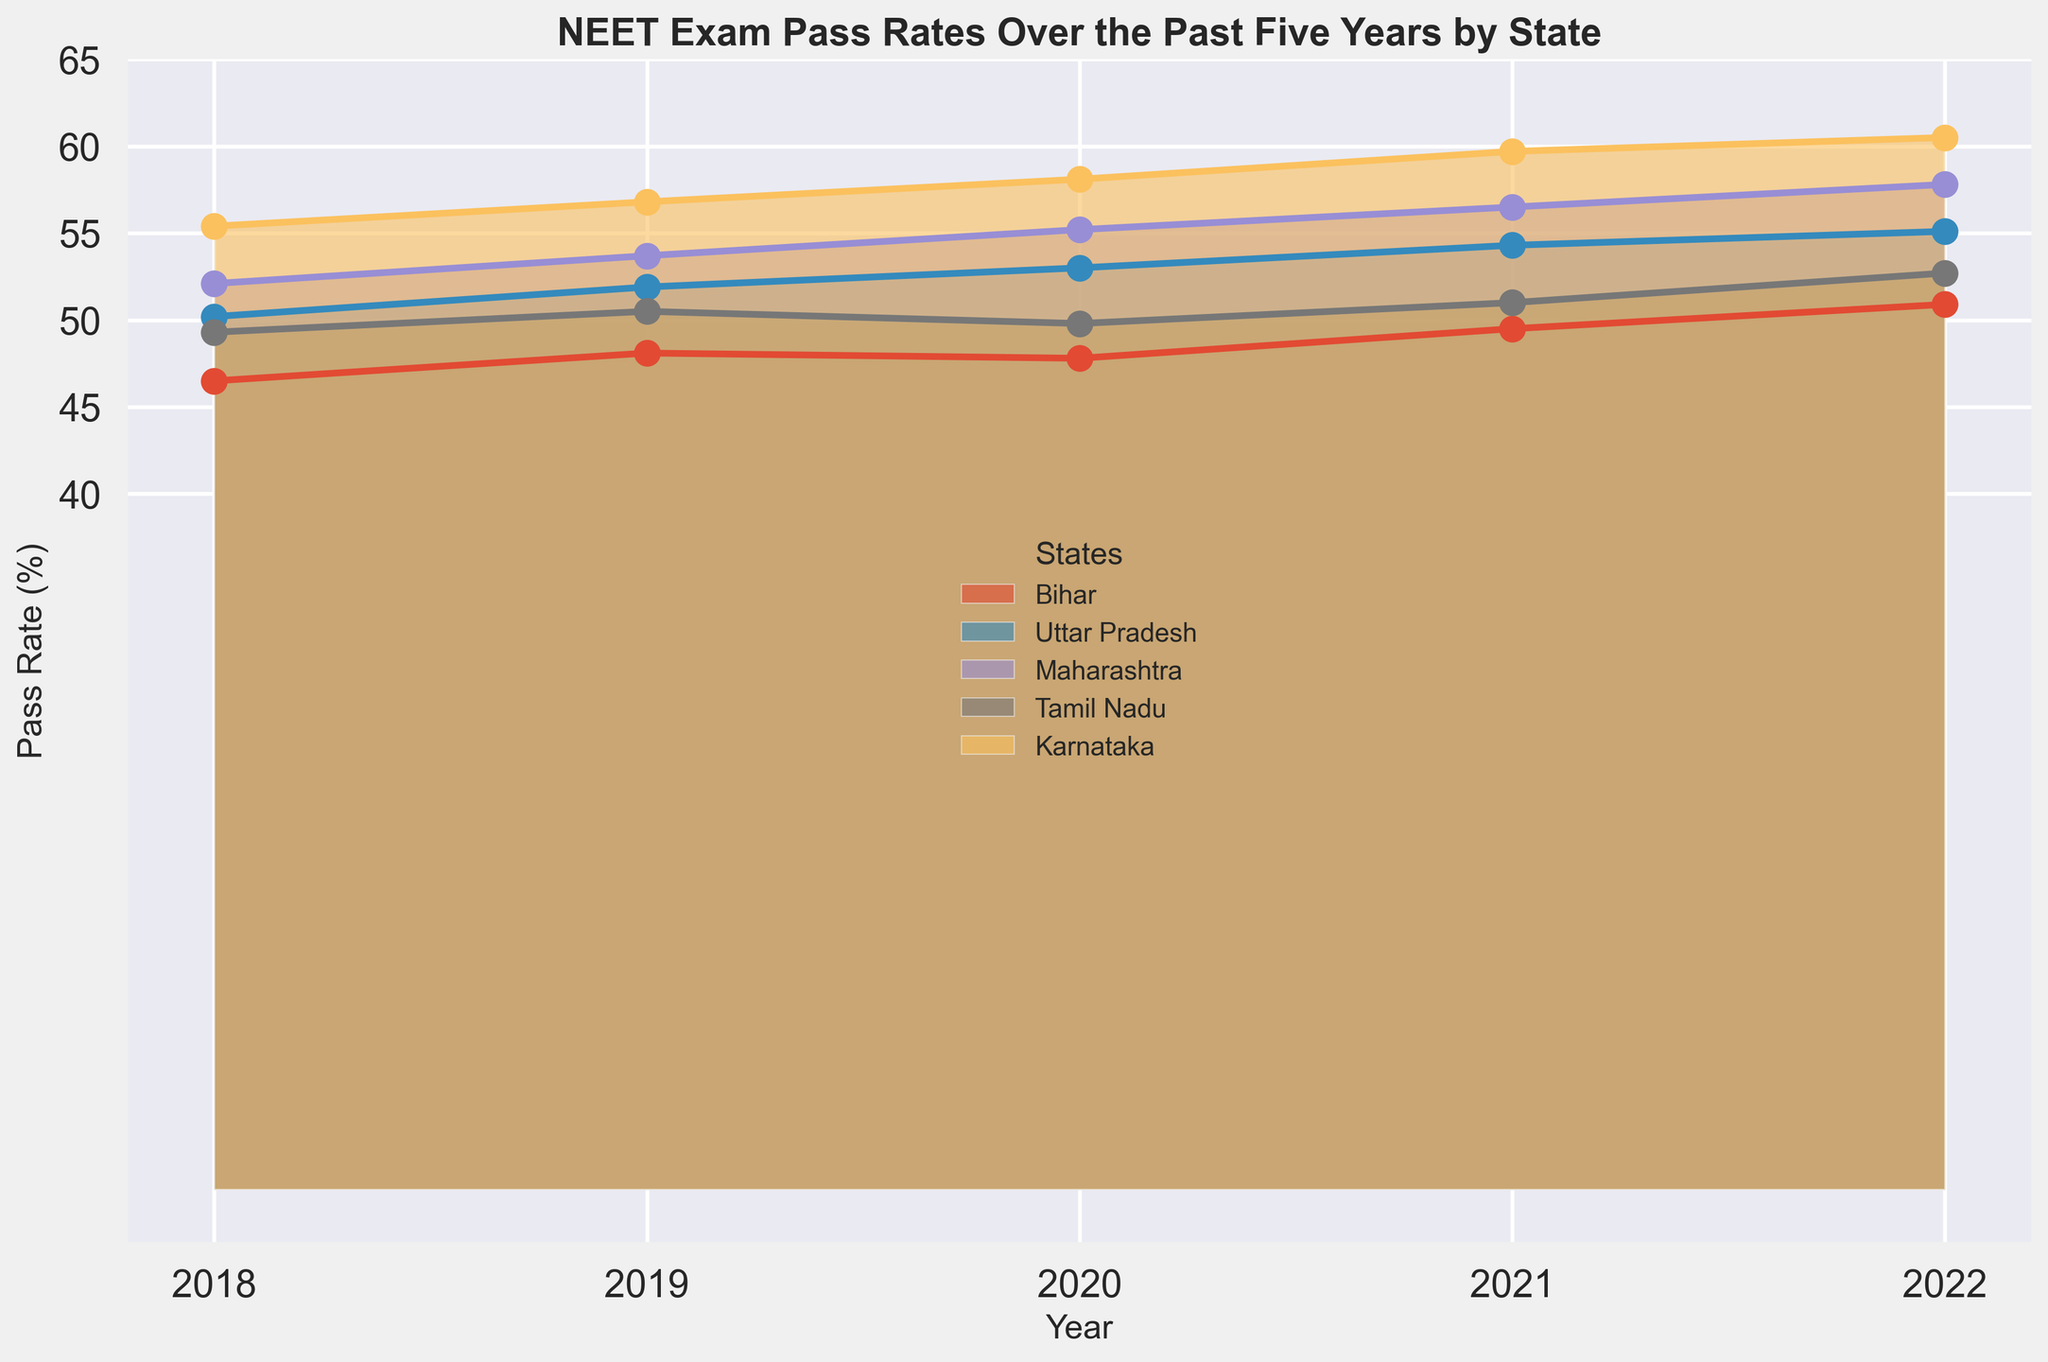What was the overall trend of NEET pass rates for Bihar over the past five years? To find the overall trend, observe the pass rates for Bihar from 2018 to 2022. The values are 46.5%, 48.1%, 47.8%, 49.5%, and 50.9%. The trend shows a general increase over the years.
Answer: Increasing Which state had the highest pass rate in 2020? To determine the highest pass rate in 2020, compare the pass rates of all states for that year. The rates are: Bihar (47.8%), Uttar Pradesh (53.0%), Maharashtra (55.2%), Tamil Nadu (49.8%), Karnataka (58.1%). Karnataka has the highest pass rate for 2020.
Answer: Karnataka What is the difference in pass rates between Bihar and Karnataka in 2022? To find the difference, subtract Bihar’s pass rate in 2022 (50.9%) from Karnataka’s pass rate in 2022 (60.5%).
Answer: 9.6% Which state showed the most consistent pass rates over the five years? To determine consistency, examine the variation in pass rates for each state from 2018 to 2022. Bihar's rates: 46.5%, 48.1%, 47.8%, 49.5%, 50.9% (small variations); Uttar Pradesh's rates: 50.2%, 51.9%, 53.0%, 54.3%, 55.1% (consistent increase); Maharashtra's rates: 52.1%, 53.7%, 55.2%, 56.5%, 57.8%(consistent increase); Tamil Nadu's rates: 49.3%, 50.5%, 49.8%, 51.0%, 52.7% (slight fluctuation); Karnataka's rates: 55.4%, 56.8%, 58.1%, 59.7%, 60.5% (consistent increase). Bihar shows more fluctuation while the other states show a consistent increase. Therefore, Uttar Pradesh, Maharashtra, or Karnataka could be candidates. However, for the least variation, Bihar shows more of an up and down indicating most consistent pass rates pattern.
Answer: Karnataka Between 2020 and 2021, which state had the largest increase in pass rate? Compare the change in pass rates from 2020 to 2021 for all states. Bihar (49.5% - 47.8% = 1.7%), Uttar Pradesh (54.3% - 53.0% = 1.3%), Maharashtra (56.5% - 55.2% = 1.3%), Tamil Nadu (51.0% - 49.8% = 1.2%), Karnataka (59.7% - 58.1% = 1.6%). Bihar had the largest increase.
Answer: Bihar How did the pass rate for Tamil Nadu change from 2018 to 2022? Evaluate the pass rate for Tamil Nadu from 2018 (49.3%) to 2022 (52.7%). The rate increased.
Answer: Increased Between Bihar and Uttar Pradesh, which state had a higher pass rate in 2019? To determine which state had a higher pass rate, compare Bihar (48.1%) and Uttar Pradesh (51.9%) in 2019.
Answer: Uttar Pradesh Which state showed the highest increase in pass rates from 2018 to 2022? Calculate the difference between 2018 and 2022 pass rates for each state: Bihar (50.9% - 46.5% = 4.4%), Uttar Pradesh (55.1% - 50.2% = 4.9%), Maharashtra (57.8% - 52.1% = 5.7%), Tamil Nadu (52.7% - 49.3% = 3.4%), Karnataka (60.5% - 55.4% = 5.1%). Check which state's increase is the highest. The highest increase is seen in Maharashtra at 5.7%
Answer: Maharashtra 